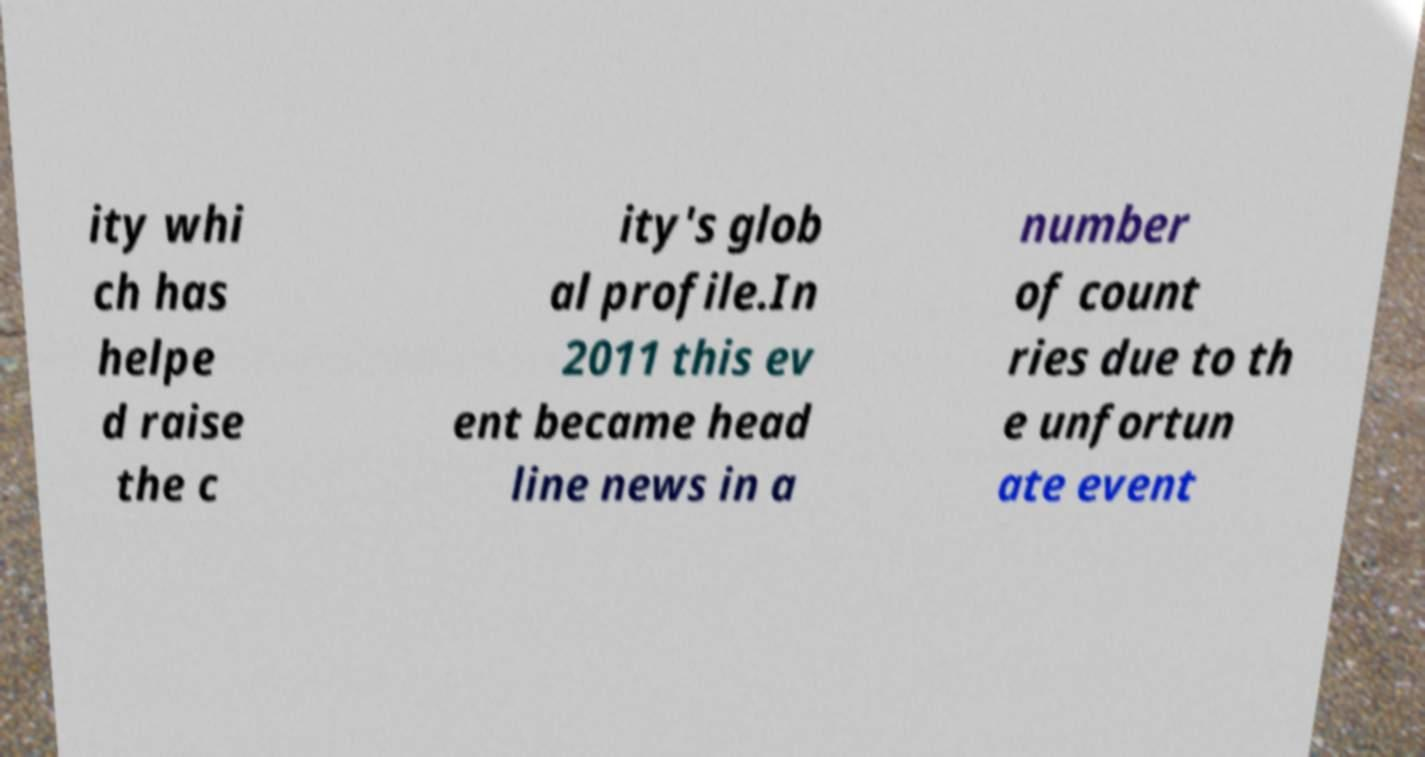For documentation purposes, I need the text within this image transcribed. Could you provide that? ity whi ch has helpe d raise the c ity's glob al profile.In 2011 this ev ent became head line news in a number of count ries due to th e unfortun ate event 